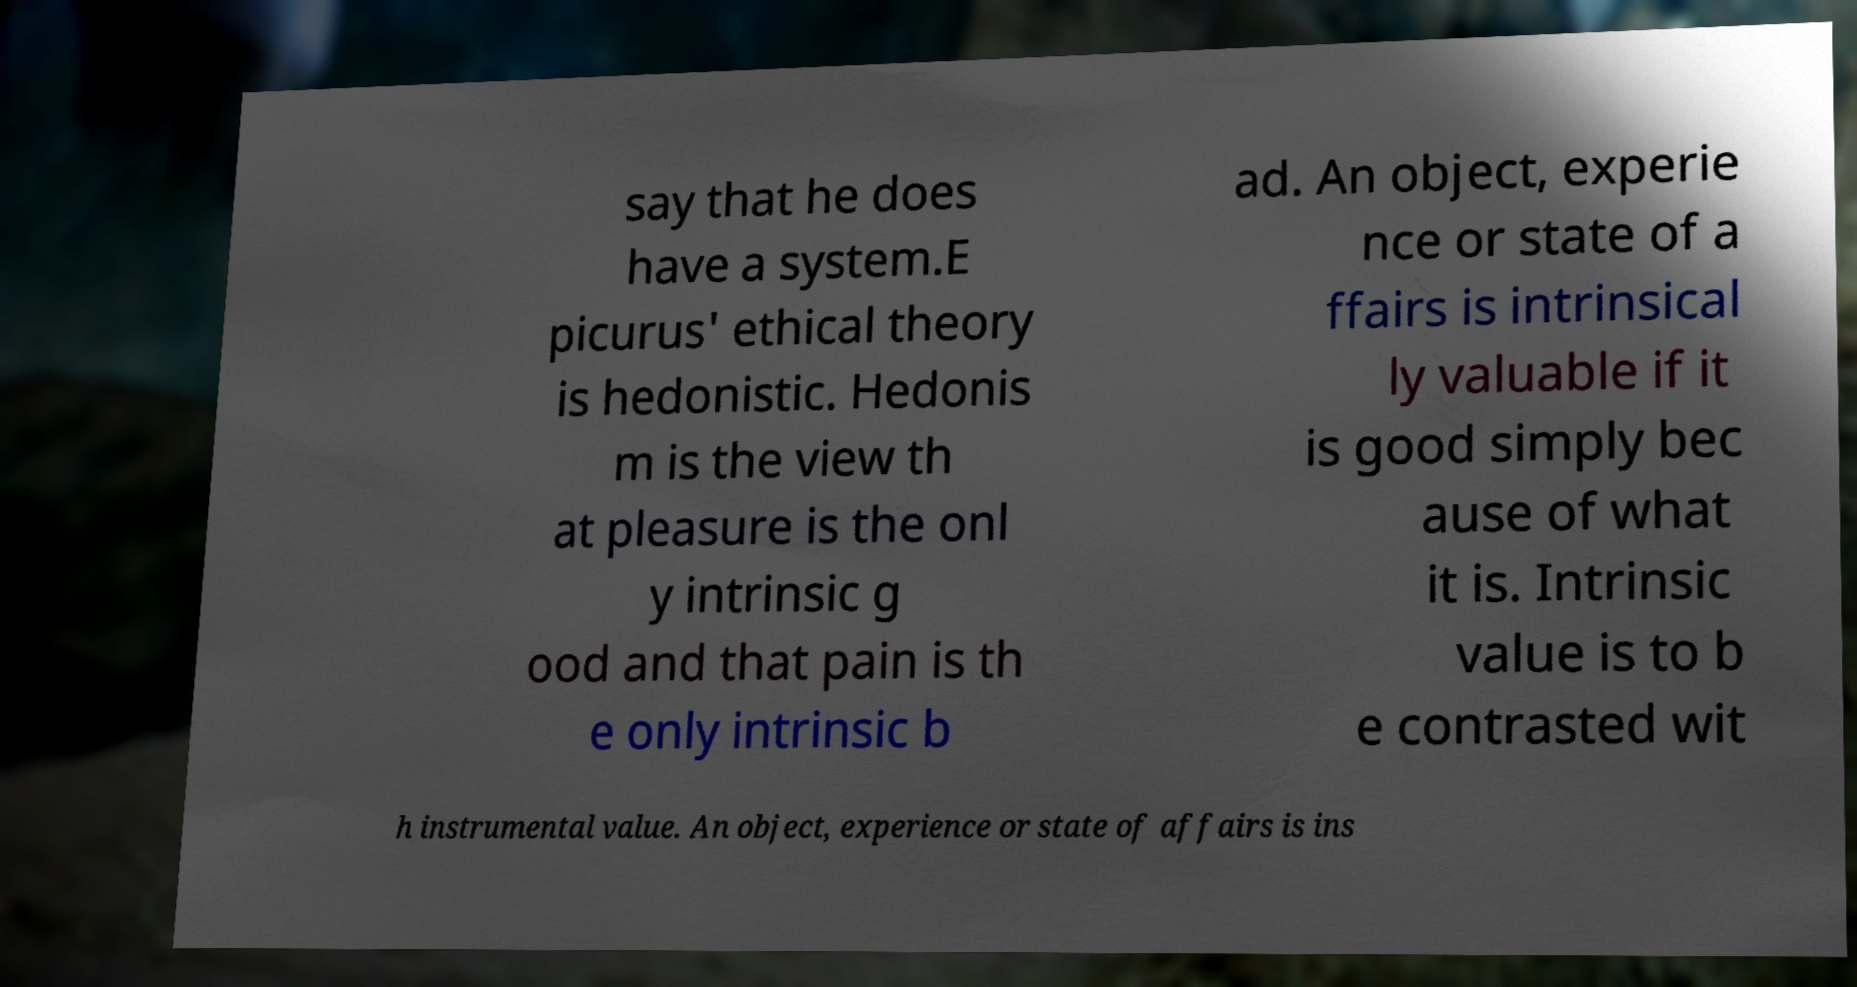Please identify and transcribe the text found in this image. say that he does have a system.E picurus' ethical theory is hedonistic. Hedonis m is the view th at pleasure is the onl y intrinsic g ood and that pain is th e only intrinsic b ad. An object, experie nce or state of a ffairs is intrinsical ly valuable if it is good simply bec ause of what it is. Intrinsic value is to b e contrasted wit h instrumental value. An object, experience or state of affairs is ins 